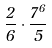<formula> <loc_0><loc_0><loc_500><loc_500>\frac { 2 } { 6 } \cdot \frac { 7 ^ { 6 } } { 5 }</formula> 